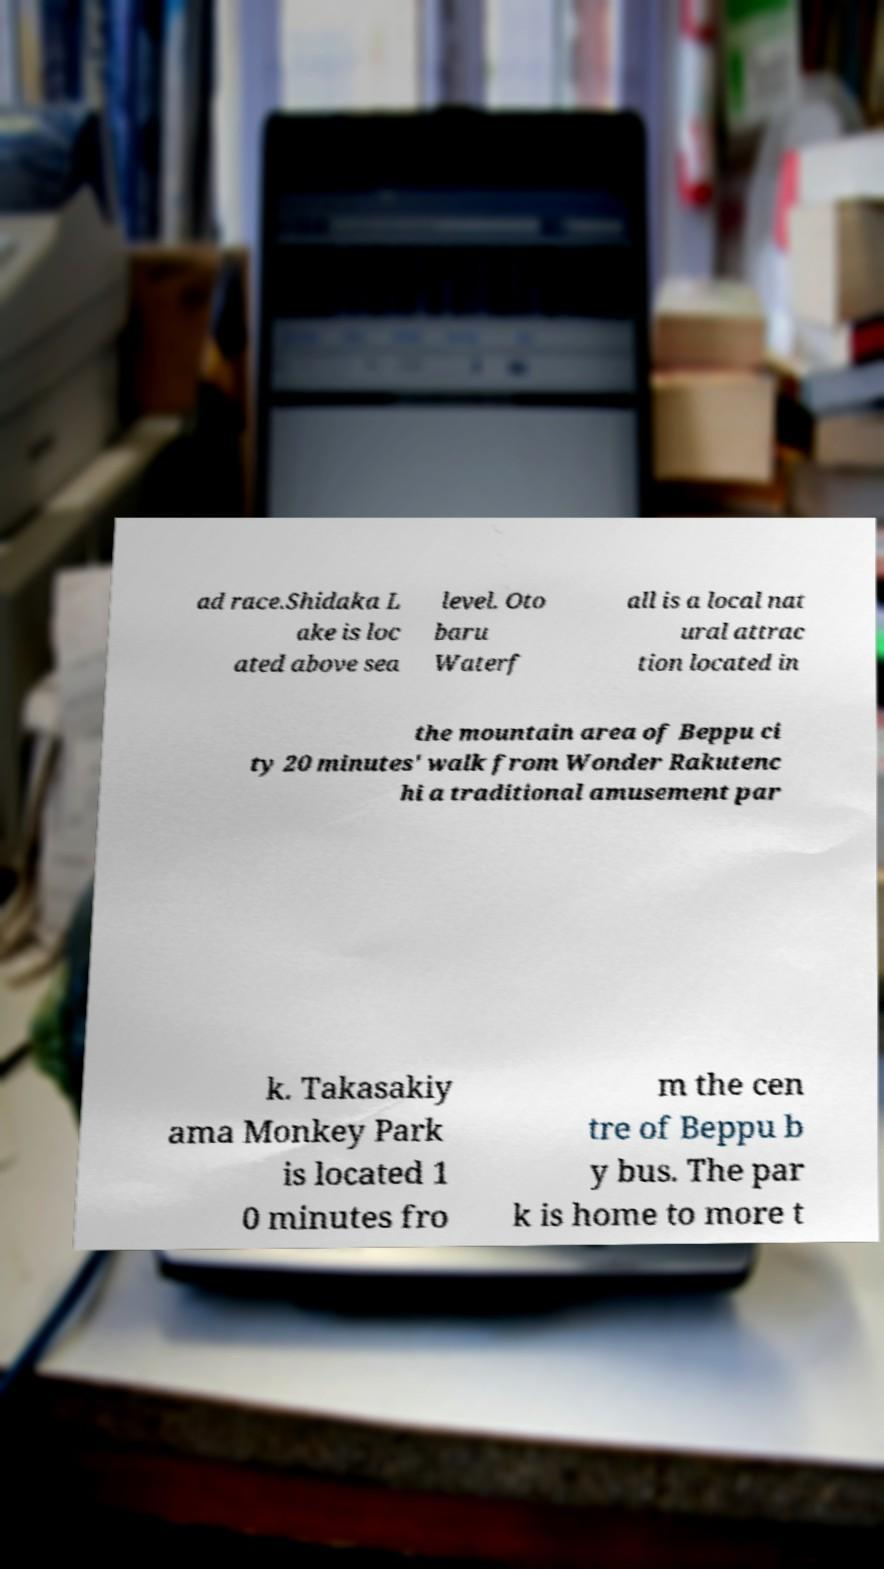Could you assist in decoding the text presented in this image and type it out clearly? ad race.Shidaka L ake is loc ated above sea level. Oto baru Waterf all is a local nat ural attrac tion located in the mountain area of Beppu ci ty 20 minutes' walk from Wonder Rakutenc hi a traditional amusement par k. Takasakiy ama Monkey Park is located 1 0 minutes fro m the cen tre of Beppu b y bus. The par k is home to more t 